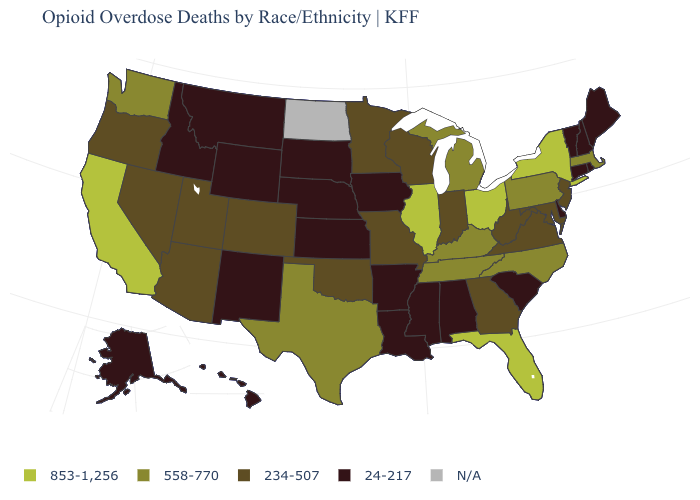Name the states that have a value in the range N/A?
Keep it brief. North Dakota. What is the value of Ohio?
Give a very brief answer. 853-1,256. What is the highest value in the Northeast ?
Be succinct. 853-1,256. What is the value of Connecticut?
Answer briefly. 24-217. Which states have the highest value in the USA?
Give a very brief answer. California, Florida, Illinois, New York, Ohio. Name the states that have a value in the range 853-1,256?
Short answer required. California, Florida, Illinois, New York, Ohio. Among the states that border New York , which have the highest value?
Be succinct. Massachusetts, Pennsylvania. Name the states that have a value in the range 558-770?
Be succinct. Kentucky, Massachusetts, Michigan, North Carolina, Pennsylvania, Tennessee, Texas, Washington. What is the value of Maine?
Write a very short answer. 24-217. Name the states that have a value in the range 853-1,256?
Answer briefly. California, Florida, Illinois, New York, Ohio. Does the first symbol in the legend represent the smallest category?
Be succinct. No. What is the lowest value in the USA?
Short answer required. 24-217. 